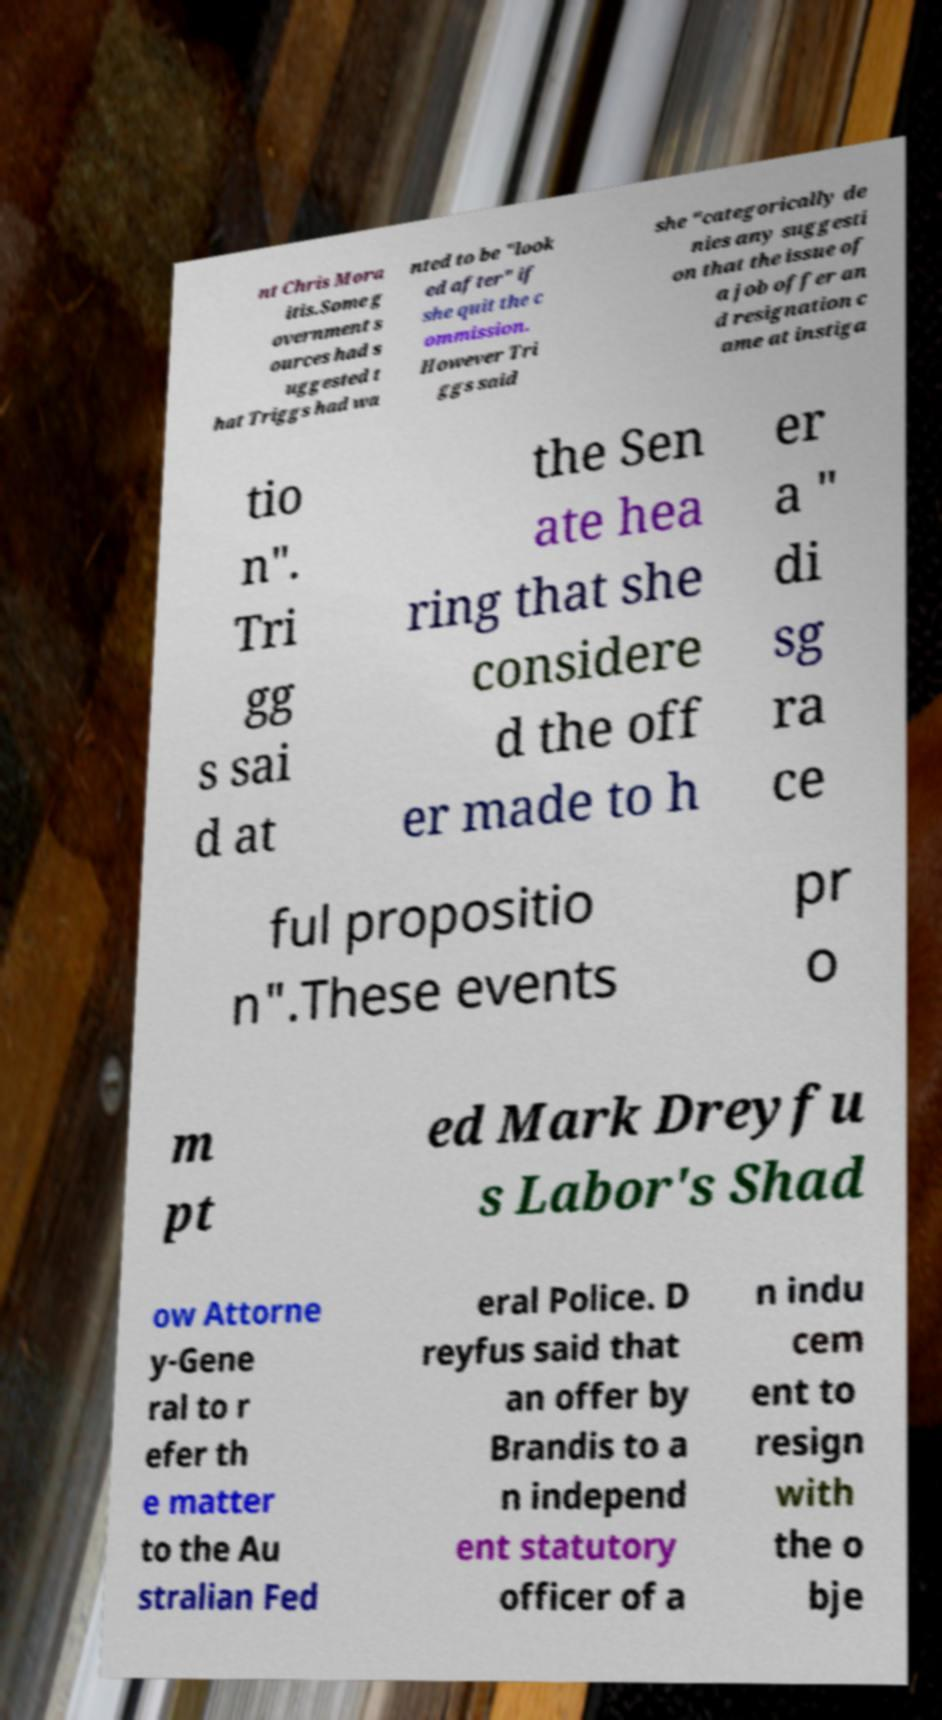I need the written content from this picture converted into text. Can you do that? nt Chris Mora itis.Some g overnment s ources had s uggested t hat Triggs had wa nted to be "look ed after" if she quit the c ommission. However Tri ggs said she "categorically de nies any suggesti on that the issue of a job offer an d resignation c ame at instiga tio n". Tri gg s sai d at the Sen ate hea ring that she considere d the off er made to h er a " di sg ra ce ful propositio n".These events pr o m pt ed Mark Dreyfu s Labor's Shad ow Attorne y-Gene ral to r efer th e matter to the Au stralian Fed eral Police. D reyfus said that an offer by Brandis to a n independ ent statutory officer of a n indu cem ent to resign with the o bje 